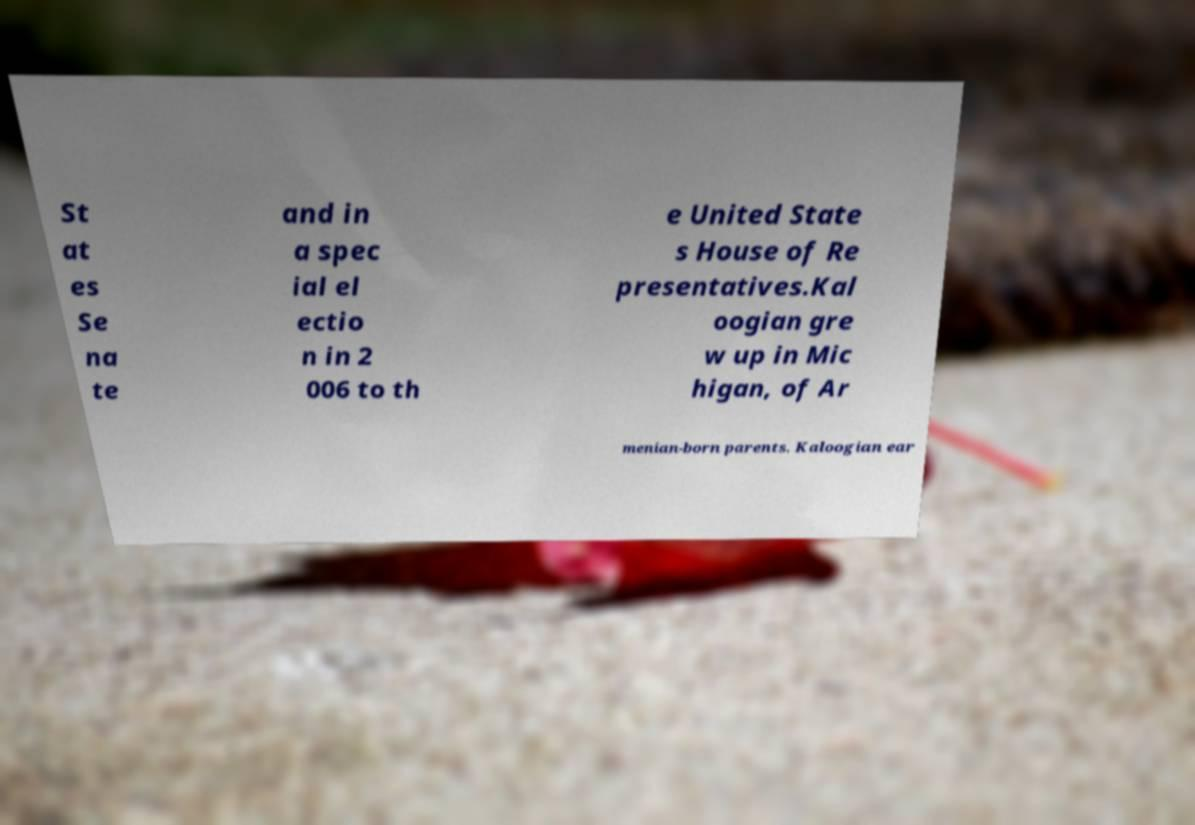Can you accurately transcribe the text from the provided image for me? St at es Se na te and in a spec ial el ectio n in 2 006 to th e United State s House of Re presentatives.Kal oogian gre w up in Mic higan, of Ar menian-born parents. Kaloogian ear 